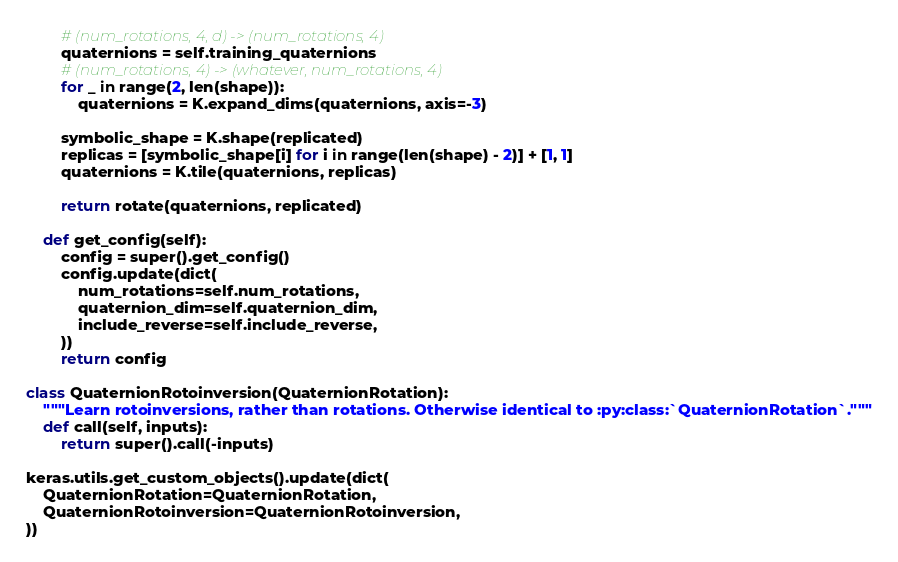<code> <loc_0><loc_0><loc_500><loc_500><_Python_>
        # (num_rotations, 4, d) -> (num_rotations, 4)
        quaternions = self.training_quaternions
        # (num_rotations, 4) -> (whatever, num_rotations, 4)
        for _ in range(2, len(shape)):
            quaternions = K.expand_dims(quaternions, axis=-3)

        symbolic_shape = K.shape(replicated)
        replicas = [symbolic_shape[i] for i in range(len(shape) - 2)] + [1, 1]
        quaternions = K.tile(quaternions, replicas)

        return rotate(quaternions, replicated)

    def get_config(self):
        config = super().get_config()
        config.update(dict(
            num_rotations=self.num_rotations,
            quaternion_dim=self.quaternion_dim,
            include_reverse=self.include_reverse,
        ))
        return config

class QuaternionRotoinversion(QuaternionRotation):
    """Learn rotoinversions, rather than rotations. Otherwise identical to :py:class:`QuaternionRotation`."""
    def call(self, inputs):
        return super().call(-inputs)

keras.utils.get_custom_objects().update(dict(
    QuaternionRotation=QuaternionRotation,
    QuaternionRotoinversion=QuaternionRotoinversion,
))
</code> 